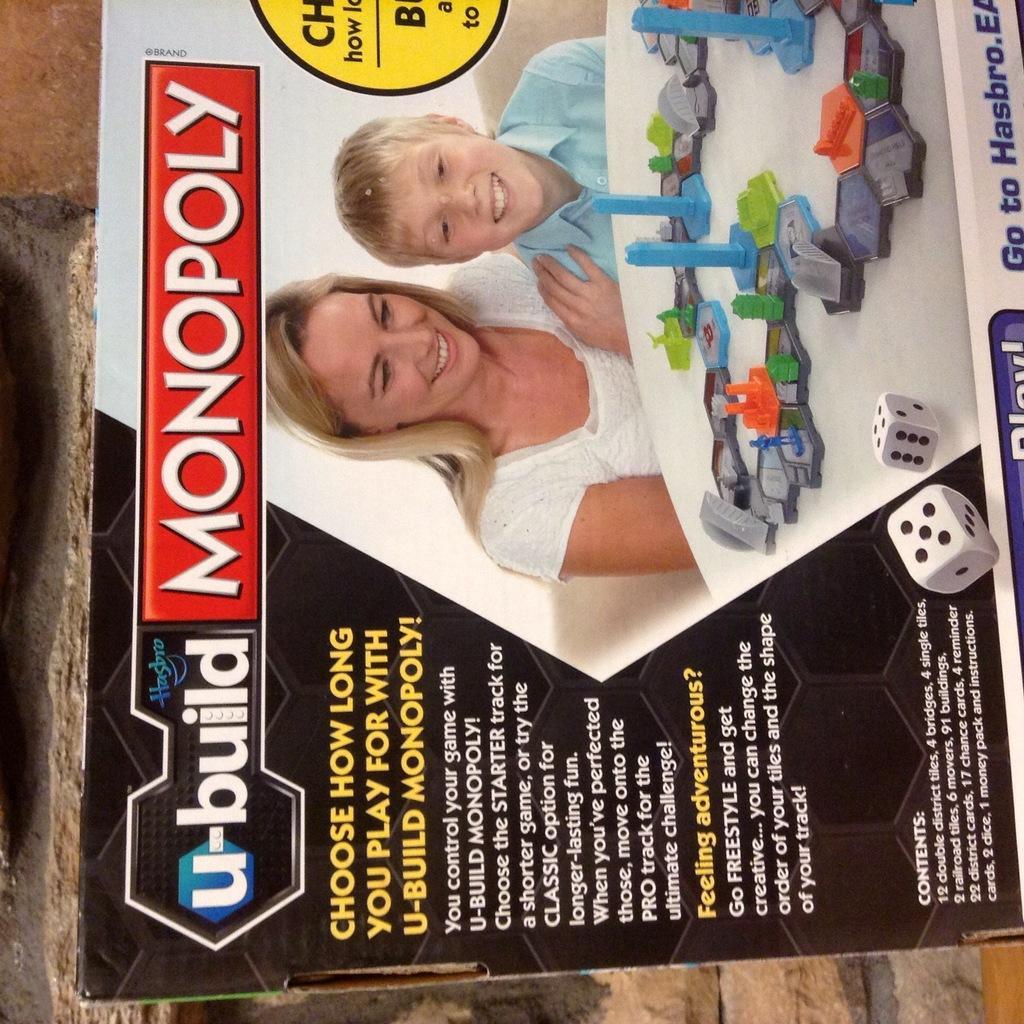How would you summarize this image in a sentence or two? In this image there is a box on that box there is some text, dies and a woman and a boy. 